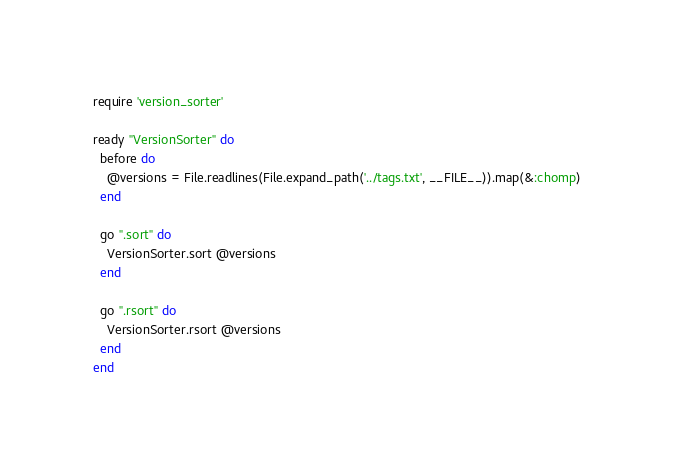<code> <loc_0><loc_0><loc_500><loc_500><_Ruby_>require 'version_sorter'

ready "VersionSorter" do
  before do
    @versions = File.readlines(File.expand_path('../tags.txt', __FILE__)).map(&:chomp)
  end

  go ".sort" do
    VersionSorter.sort @versions
  end

  go ".rsort" do
    VersionSorter.rsort @versions
  end
end
</code> 